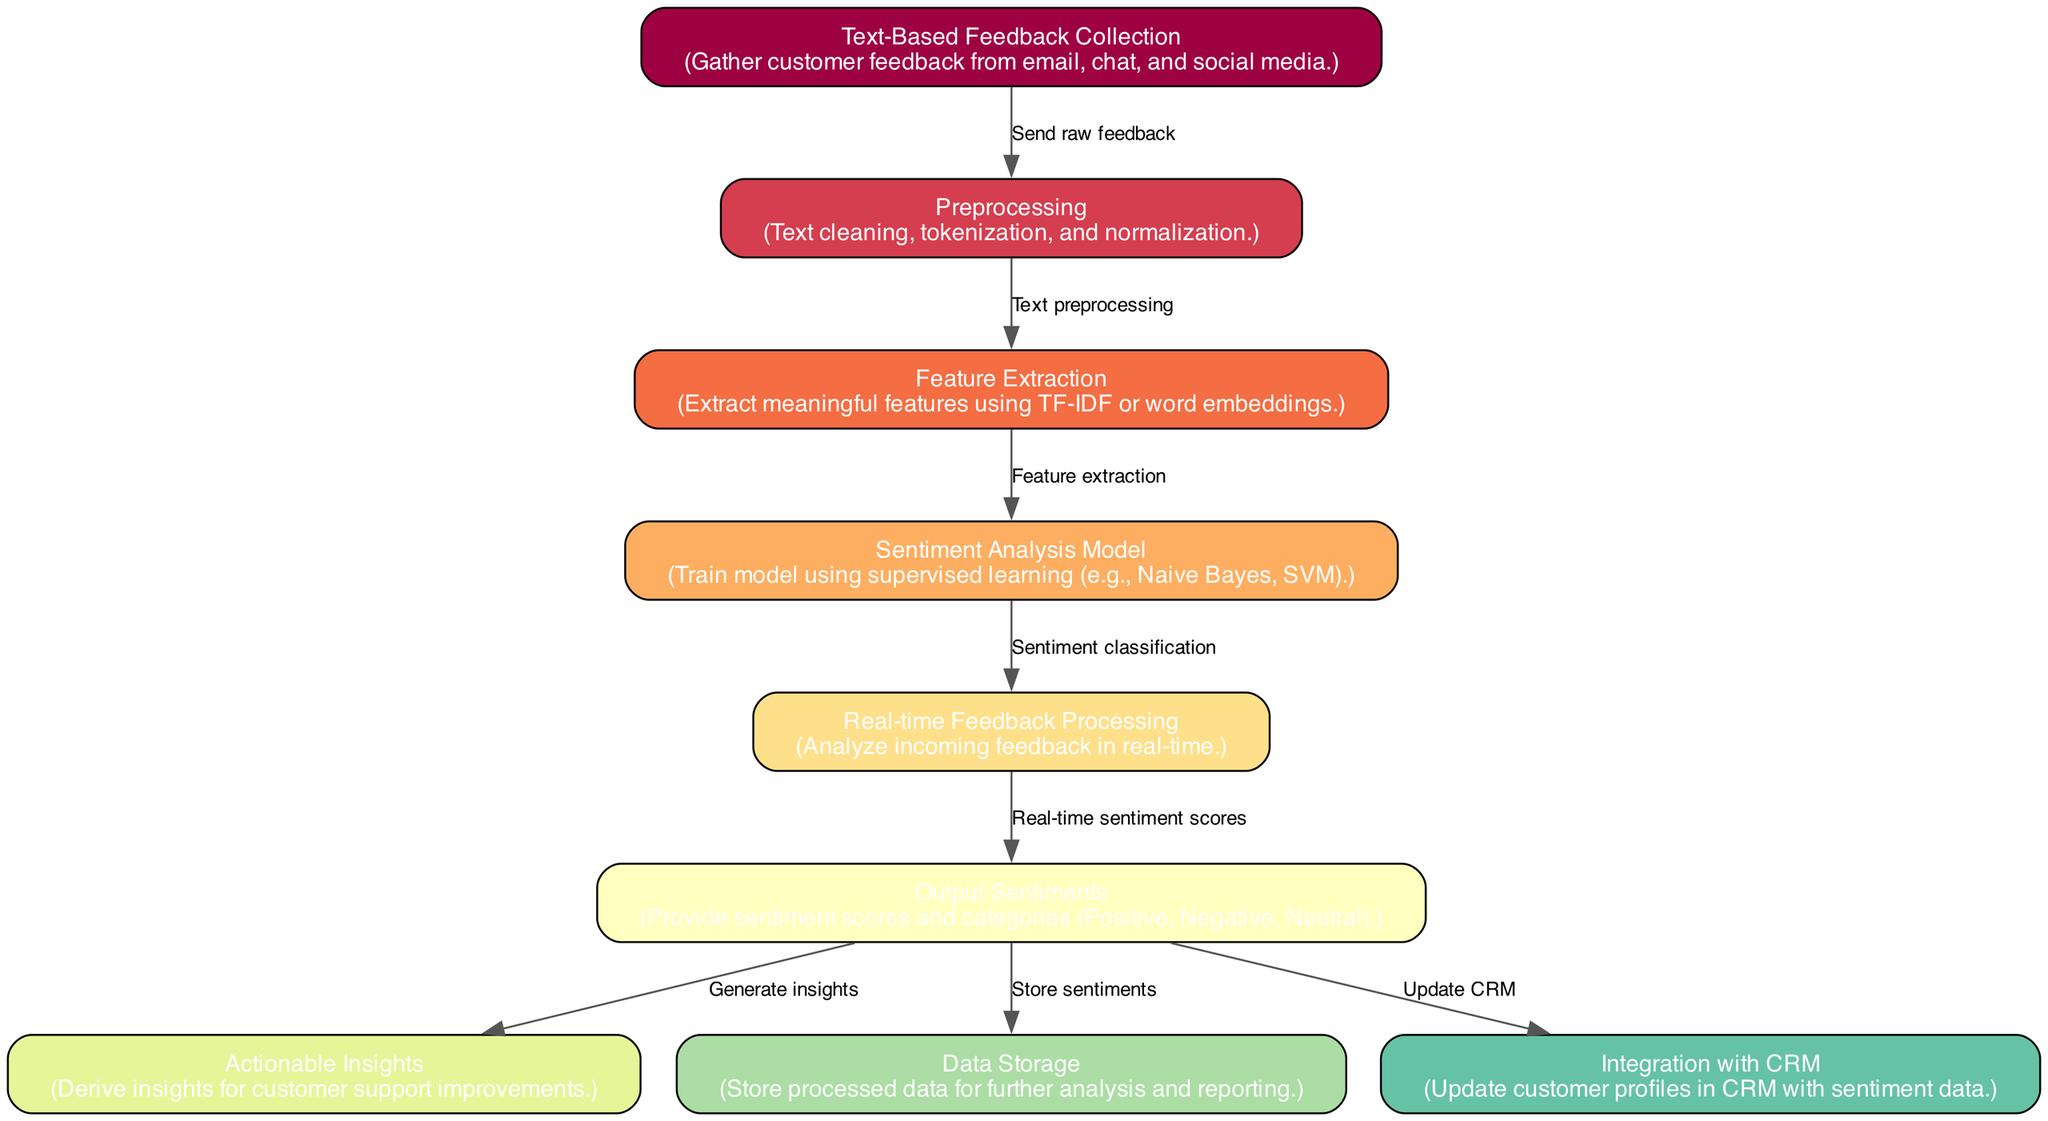What is the total number of nodes in the diagram? The diagram describes 9 distinct nodes, each representing a different step in the sentiment analysis process. Simply counting the nodes listed in the data confirms this total.
Answer: 9 Which node collects the feedback? The first node in the diagram is labeled "Text-Based Feedback Collection," which is responsible for gathering customer feedback from various platforms such as email, chat, and social media.
Answer: Text-Based Feedback Collection What type of model is trained in the diagram? The "Sentiment Analysis Model" node indicates that a supervised learning model, such as Naive Bayes or SVM, is used for sentiment classification, specifically trained on the features extracted from the feedback data.
Answer: Supervised learning model Which node directly follows "Feature Extraction"? The diagram shows that the "Sentiment Analysis Model" node directly follows "Feature Extraction," as indicated by the edge leading from the feature extraction step to the model training step.
Answer: Sentiment Analysis Model How many edges are there connecting the nodes? The diagram contains 8 edges, which represent the flow of information between the various nodes from feedback collection to actionable insights. Counting these edges in the data provides the total.
Answer: 8 What are the sentiment categories generated in the diagram? The "Output Sentiments" node specifies that sentiment scores and categories produced include Positive, Negative, and Neutral, summarizing the outcomes of the sentiment analysis process.
Answer: Positive, Negative, Neutral Which node is responsible for generating actionable insights? The node labeled "Actionable Insights," which is connected to the "Output Sentiments" node, is responsible for deriving insights that can lead to improvements in customer support based on the sentiment analysis output.
Answer: Actionable Insights In which step is data stored for further analysis? The "Data Storage" node indicates that there is a specific step dedicated to storing processed data, which is crucial for future analysis and reporting, tied to the outputs of the sentiment analysis.
Answer: Data Storage What happens to sentiment data after it is generated? The diagram shows that the generated sentiment data can be stored, generate insights, and update customer profiles in CRM systems, evidencing a multi-faceted approach in processing the sentiment data.
Answer: Store, Generate insights, Update CRM 